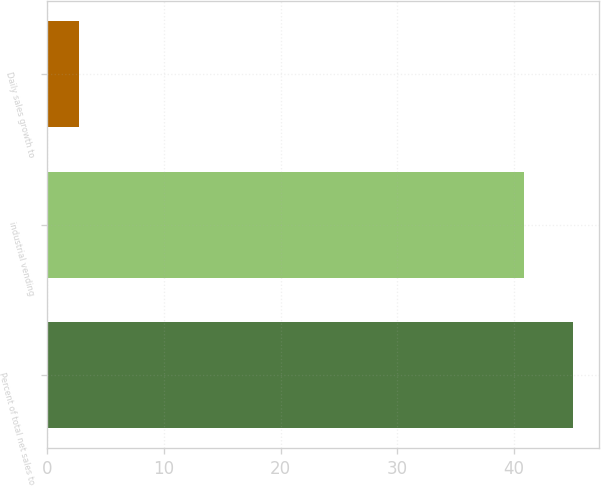Convert chart. <chart><loc_0><loc_0><loc_500><loc_500><bar_chart><fcel>Percent of total net sales to<fcel>industrial vending<fcel>Daily sales growth to<nl><fcel>45.09<fcel>40.9<fcel>2.7<nl></chart> 